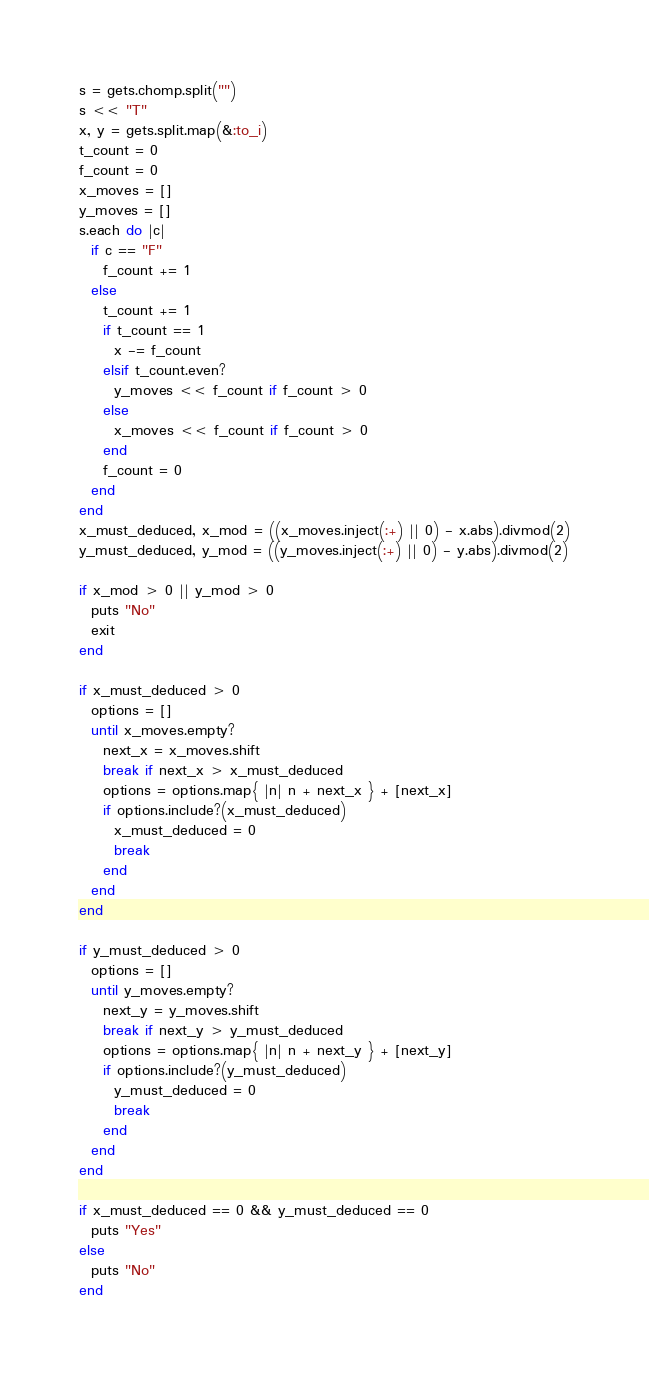Convert code to text. <code><loc_0><loc_0><loc_500><loc_500><_Ruby_>s = gets.chomp.split("")
s << "T"
x, y = gets.split.map(&:to_i)
t_count = 0
f_count = 0
x_moves = []
y_moves = []
s.each do |c|
  if c == "F"
    f_count += 1
  else
    t_count += 1
    if t_count == 1
      x -= f_count
    elsif t_count.even?
      y_moves << f_count if f_count > 0
    else
      x_moves << f_count if f_count > 0
    end
    f_count = 0
  end
end
x_must_deduced, x_mod = ((x_moves.inject(:+) || 0) - x.abs).divmod(2)
y_must_deduced, y_mod = ((y_moves.inject(:+) || 0) - y.abs).divmod(2)

if x_mod > 0 || y_mod > 0
  puts "No"
  exit
end

if x_must_deduced > 0
  options = []
  until x_moves.empty?
    next_x = x_moves.shift
    break if next_x > x_must_deduced
    options = options.map{ |n| n + next_x } + [next_x]
    if options.include?(x_must_deduced)
      x_must_deduced = 0
      break
    end
  end
end

if y_must_deduced > 0
  options = []
  until y_moves.empty?
    next_y = y_moves.shift
    break if next_y > y_must_deduced
    options = options.map{ |n| n + next_y } + [next_y]
    if options.include?(y_must_deduced)
      y_must_deduced = 0
      break
    end
  end
end

if x_must_deduced == 0 && y_must_deduced == 0
  puts "Yes"
else
  puts "No"
end
</code> 